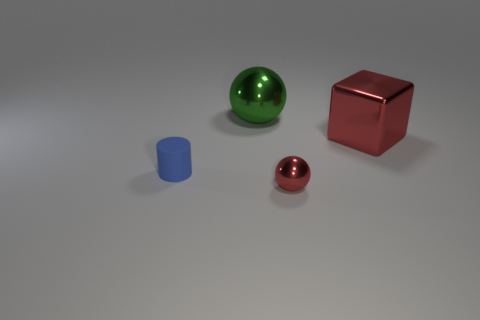If these objects were part of a scale model, what might the model represent? These objects could represent a stylized architectural model with the cube and cylinder symbolizing buildings and the spheres perhaps indicating landscaping features or ornamental elements. Alternatively, considering their simplicity, they could be part of a teaching aid for geometry or a conceptual art piece where the focus is on form and material. 